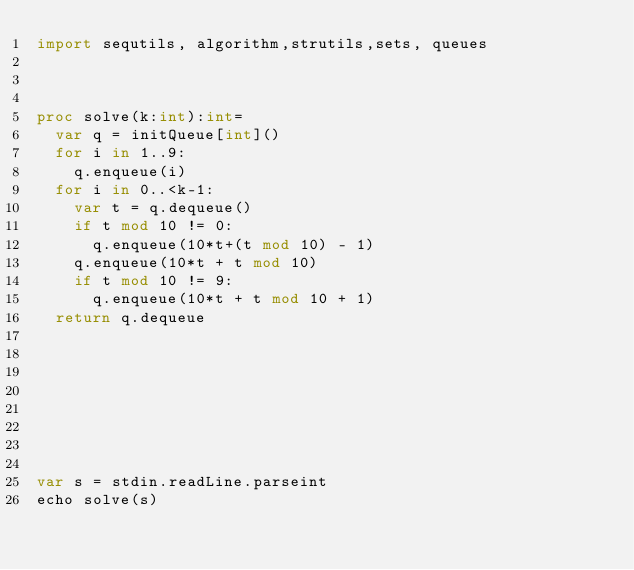Convert code to text. <code><loc_0><loc_0><loc_500><loc_500><_Nim_>import sequtils, algorithm,strutils,sets, queues



proc solve(k:int):int=
  var q = initQueue[int]()
  for i in 1..9:
    q.enqueue(i)
  for i in 0..<k-1:
    var t = q.dequeue()
    if t mod 10 != 0:
      q.enqueue(10*t+(t mod 10) - 1)
    q.enqueue(10*t + t mod 10)
    if t mod 10 != 9:
      q.enqueue(10*t + t mod 10 + 1)
  return q.dequeue

      






var s = stdin.readLine.parseint
echo solve(s)</code> 